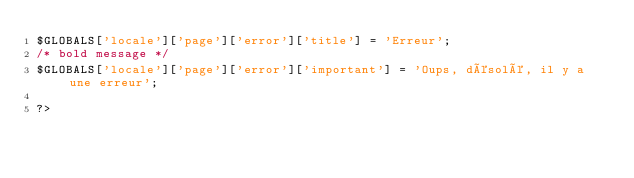<code> <loc_0><loc_0><loc_500><loc_500><_PHP_>$GLOBALS['locale']['page']['error']['title'] = 'Erreur';
/* bold message */
$GLOBALS['locale']['page']['error']['important'] = 'Oups, désolé, il y a une erreur';

?>
</code> 